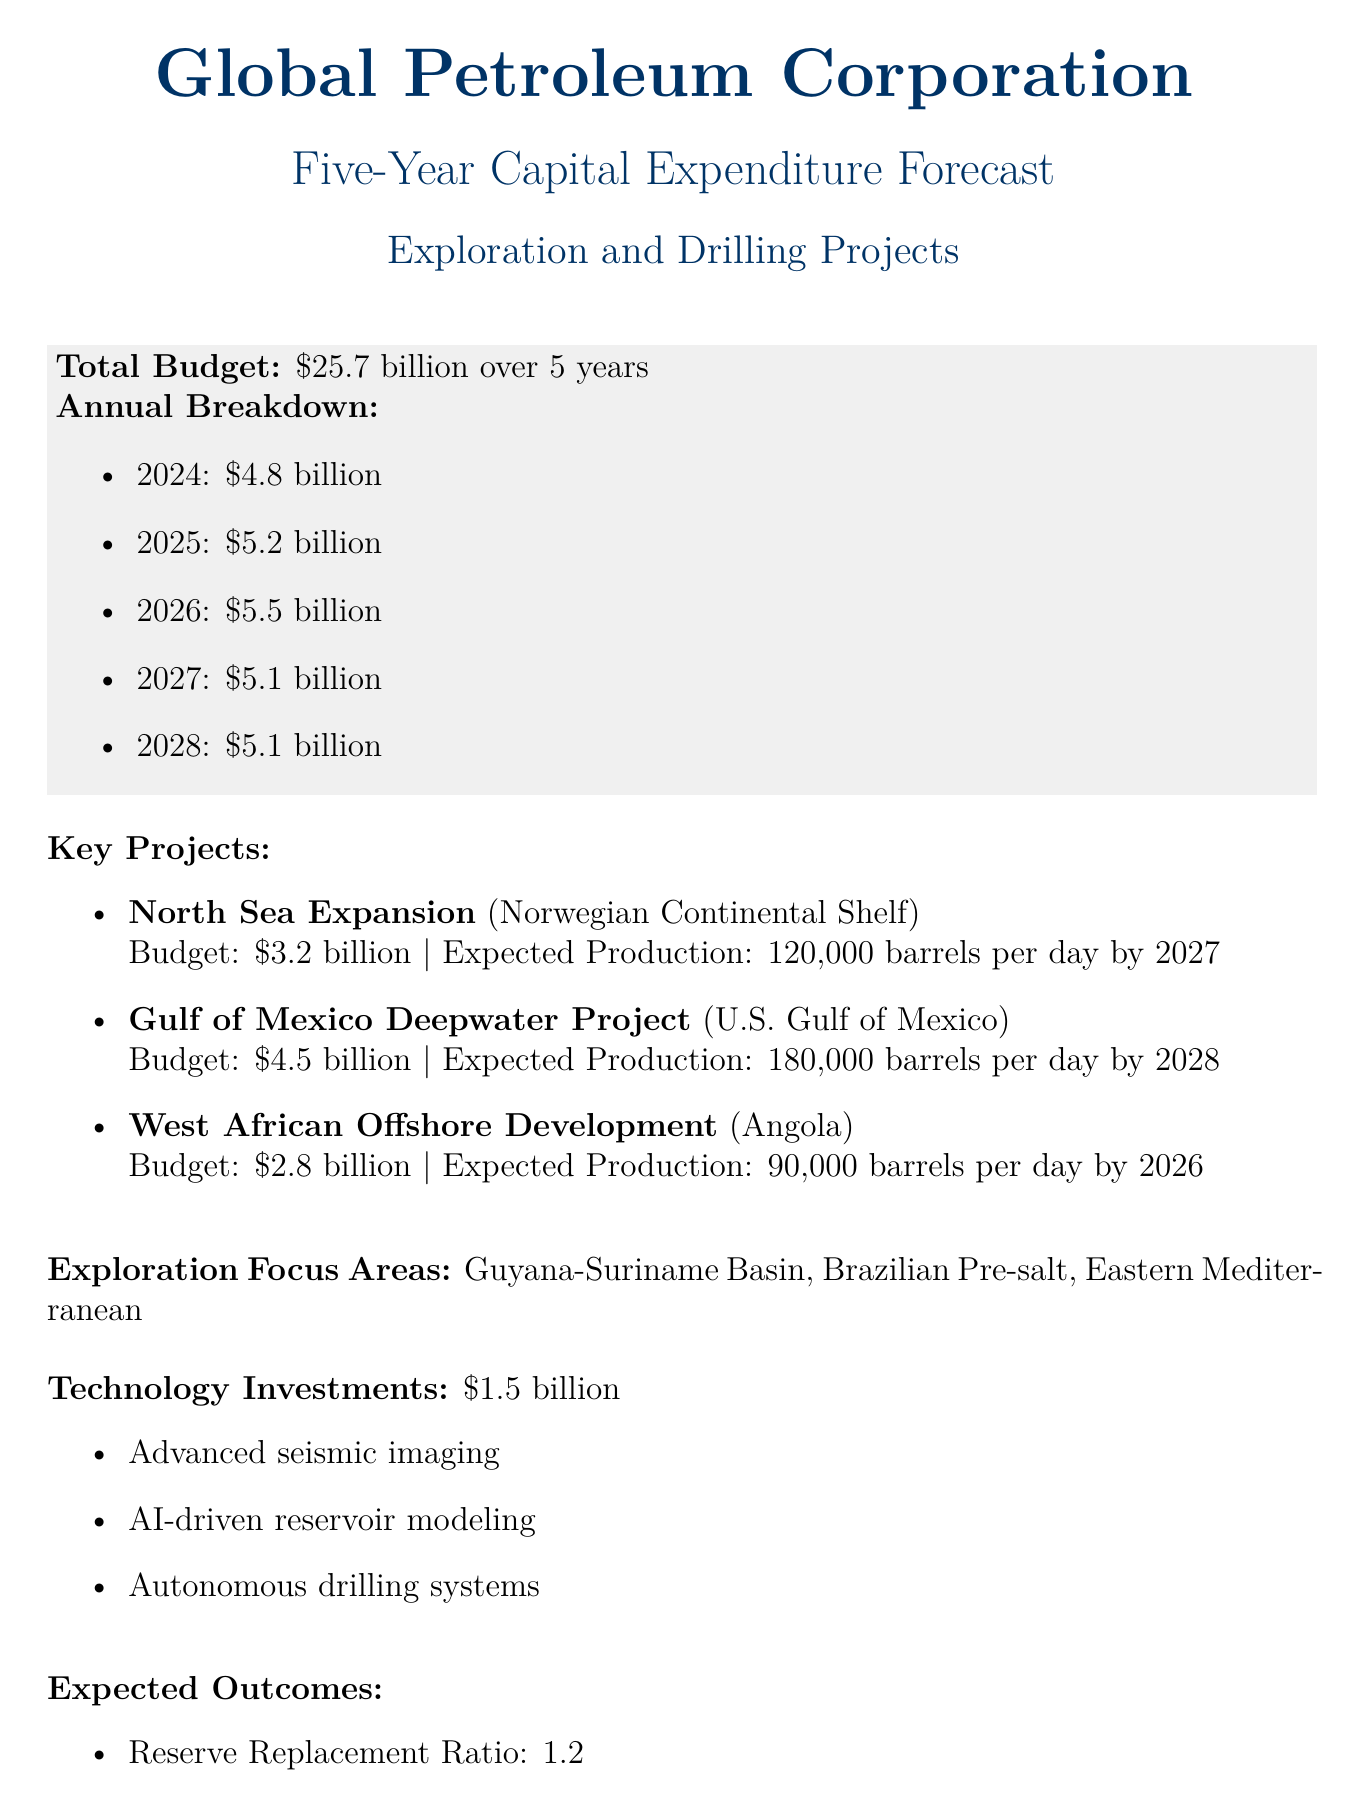What is the total capital expenditure budget? The total budget is explicitly stated in the document as $25.7 billion.
Answer: $25.7 billion What is the expected production from the Gulf of Mexico Deepwater Project? The expected production from this project is specified to be 180,000 barrels per day by 2028.
Answer: 180,000 barrels per day by 2028 How much is allocated for technology investments? The budget for technology investments is clearly indicated as $1.5 billion.
Answer: $1.5 billion What is the reserve replacement ratio? The reserve replacement ratio is mentioned in the expected outcomes section and is given as 1.2.
Answer: 1.2 Which year has the highest annual budget? By comparing the annual breakdown amounts, 2026 has the highest budget of $5.5 billion.
Answer: $5.5 billion What is one of the key exploration focus areas? The document lists multiple exploration focus areas, one of which is the Guyana-Suriname Basin.
Answer: Guyana-Suriname Basin What are the key risks mentioned in the document? The document specifies several risk factors, one of which is oil price volatility.
Answer: Oil price volatility What is the production growth rate expected over five years? The expected production growth is quantified with a CAGR of 3.5%.
Answer: 3.5% CAGR What is the budget for the West African Offshore Development project? The budget for this key project is stated as $2.8 billion.
Answer: $2.8 billion 